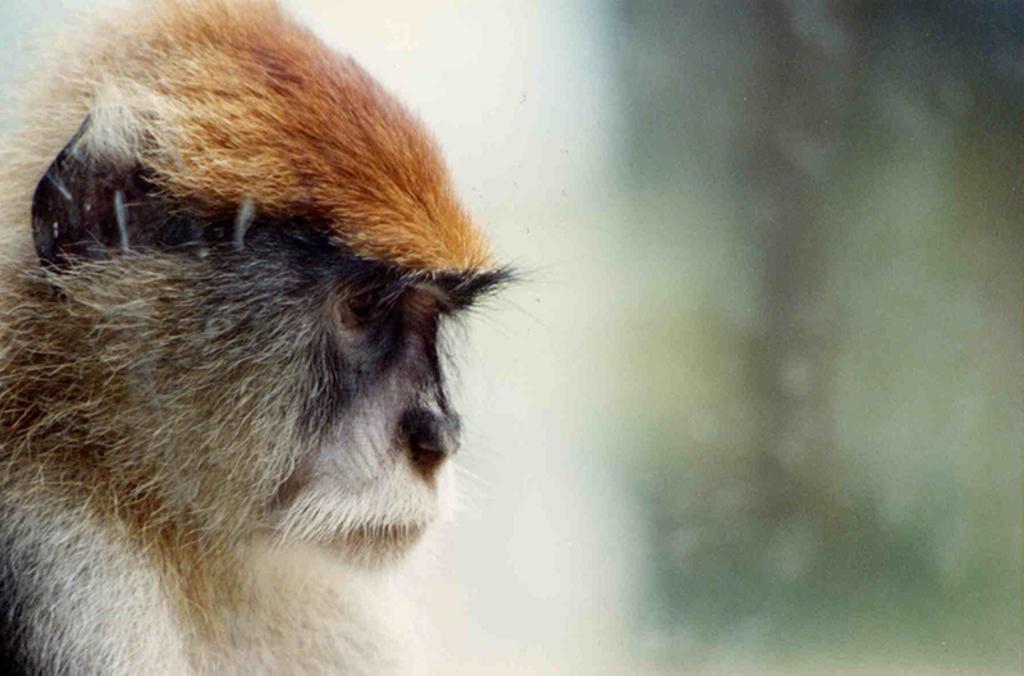Please provide a concise description of this image. Here we can see monkey. Background it is blur. 